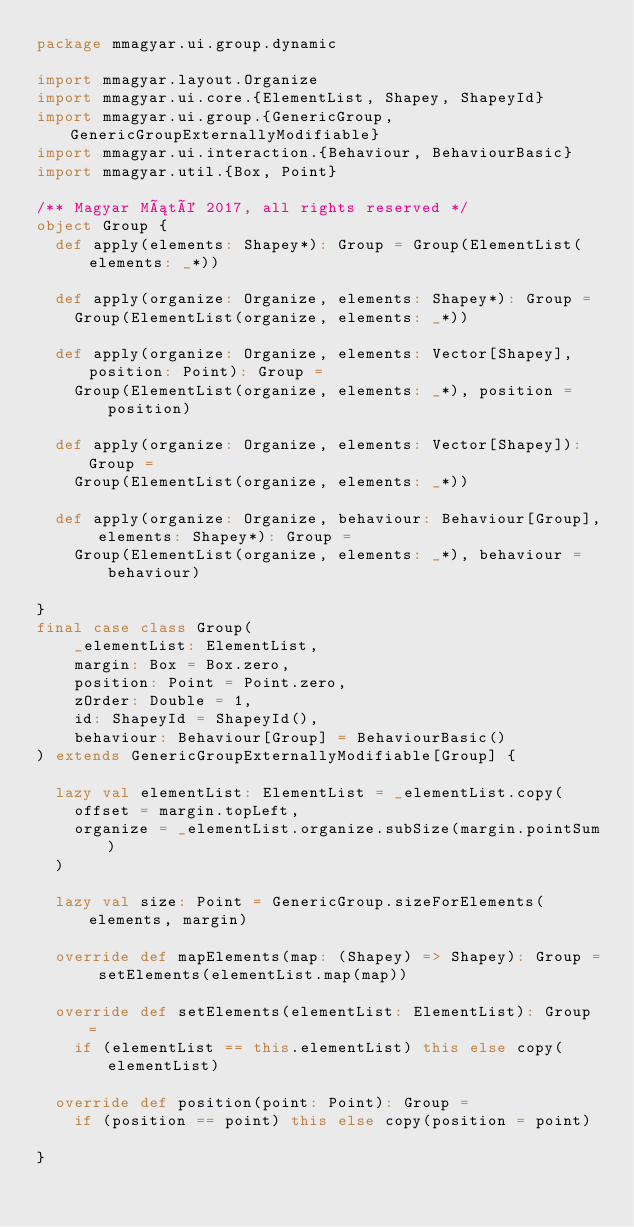Convert code to text. <code><loc_0><loc_0><loc_500><loc_500><_Scala_>package mmagyar.ui.group.dynamic

import mmagyar.layout.Organize
import mmagyar.ui.core.{ElementList, Shapey, ShapeyId}
import mmagyar.ui.group.{GenericGroup, GenericGroupExternallyModifiable}
import mmagyar.ui.interaction.{Behaviour, BehaviourBasic}
import mmagyar.util.{Box, Point}

/** Magyar Máté 2017, all rights reserved */
object Group {
  def apply(elements: Shapey*): Group = Group(ElementList(elements: _*))

  def apply(organize: Organize, elements: Shapey*): Group =
    Group(ElementList(organize, elements: _*))

  def apply(organize: Organize, elements: Vector[Shapey], position: Point): Group =
    Group(ElementList(organize, elements: _*), position = position)

  def apply(organize: Organize, elements: Vector[Shapey]): Group =
    Group(ElementList(organize, elements: _*))

  def apply(organize: Organize, behaviour: Behaviour[Group], elements: Shapey*): Group =
    Group(ElementList(organize, elements: _*), behaviour = behaviour)

}
final case class Group(
    _elementList: ElementList,
    margin: Box = Box.zero,
    position: Point = Point.zero,
    zOrder: Double = 1,
    id: ShapeyId = ShapeyId(),
    behaviour: Behaviour[Group] = BehaviourBasic()
) extends GenericGroupExternallyModifiable[Group] {

  lazy val elementList: ElementList = _elementList.copy(
    offset = margin.topLeft,
    organize = _elementList.organize.subSize(margin.pointSum)
  )

  lazy val size: Point = GenericGroup.sizeForElements(elements, margin)

  override def mapElements(map: (Shapey) => Shapey): Group = setElements(elementList.map(map))

  override def setElements(elementList: ElementList): Group =
    if (elementList == this.elementList) this else copy(elementList)

  override def position(point: Point): Group =
    if (position == point) this else copy(position = point)

}
</code> 